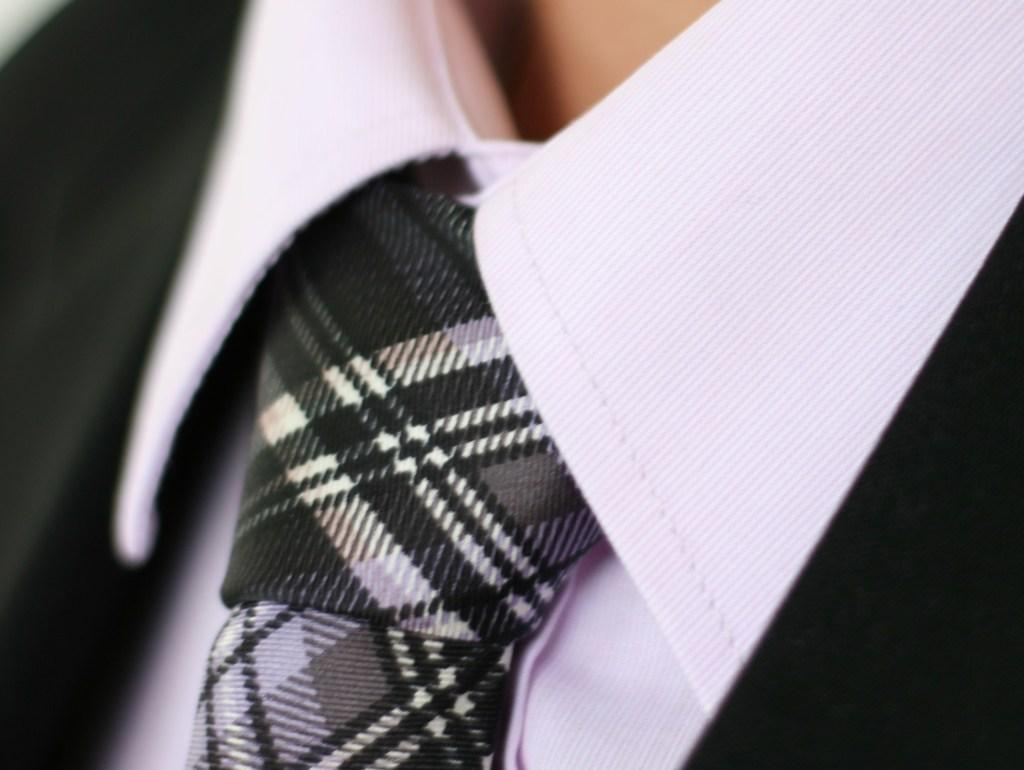What type of clothing accessory is in the image? There is a tie in the image. What type of jacket is in the image? There is a black blazer in the image. What type of clothing is worn underneath the blazer? There is a shirt in the image. What color is the lipstick worn by the person in the image? There is no lipstick or person present in the image; it only features a tie, black blazer, and shirt. How many times does the person in the image twist their hair? There is no person or hair present in the image; it only features a tie, black blazer, and shirt. 